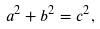Convert formula to latex. <formula><loc_0><loc_0><loc_500><loc_500>a ^ { 2 } + b ^ { 2 } = c ^ { 2 } ,</formula> 